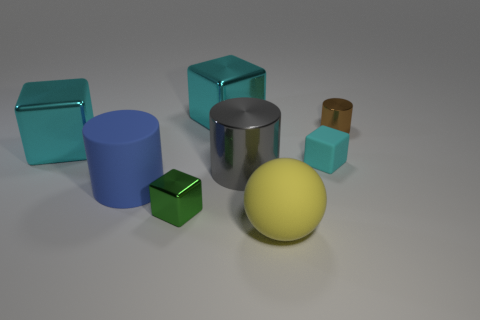The metallic block behind the object that is on the right side of the cyan cube that is to the right of the big gray cylinder is what color?
Ensure brevity in your answer.  Cyan. How many large yellow rubber balls are behind the small block that is right of the big metallic object in front of the tiny matte block?
Your answer should be very brief. 0. Is there any other thing that is the same color as the rubber block?
Offer a very short reply. Yes. Does the cube behind the brown object have the same size as the large blue thing?
Provide a succinct answer. Yes. There is a cylinder that is to the left of the green block; how many blue things are to the right of it?
Offer a very short reply. 0. Are there any brown cylinders that are right of the tiny shiny thing behind the tiny object that is on the left side of the small cyan block?
Your answer should be very brief. No. What material is the large blue thing that is the same shape as the large gray shiny thing?
Provide a succinct answer. Rubber. Is the brown cylinder made of the same material as the big blue thing on the left side of the brown cylinder?
Offer a terse response. No. What shape is the large thing behind the metallic object that is to the left of the small green shiny object?
Your answer should be very brief. Cube. What number of tiny things are either cyan objects or green blocks?
Your response must be concise. 2. 